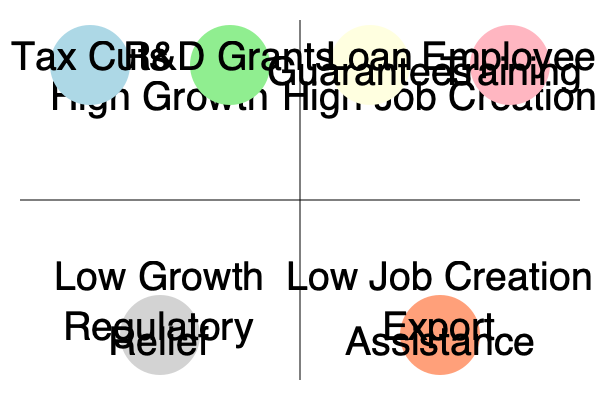Based on the decision tree diagram comparing various economic incentives for small businesses, which incentive is likely to be most effective in simultaneously promoting high growth and high job creation? Explain your reasoning using the positioning of the incentives in the quadrants. To answer this question, we need to analyze the position of each economic incentive in the decision tree diagram:

1. The diagram is divided into four quadrants:
   - Top-left: High Growth, Low Job Creation
   - Top-right: High Growth, High Job Creation
   - Bottom-left: Low Growth, Low Job Creation
   - Bottom-right: Low Growth, High Job Creation

2. The economic incentives are positioned as follows:
   - Tax Cuts: High Growth, Low Job Creation
   - R&D Grants: High Growth, Low Job Creation
   - Loan Guarantees: High Growth, High Job Creation
   - Employee Training: High Growth, High Job Creation
   - Regulatory Relief: Low Growth, Low Job Creation
   - Export Assistance: Low Growth, High Job Creation

3. To promote both high growth and high job creation, we need to focus on the top-right quadrant.

4. Two incentives are positioned in the top-right quadrant:
   - Loan Guarantees
   - Employee Training

5. Both of these incentives are expected to contribute to high growth and high job creation. However, we need to choose the most effective one.

6. Loan Guarantees can provide small businesses with access to capital, which can be used for expansion, hiring, and investment in new technologies or equipment. This can lead to both growth and job creation.

7. Employee Training, while beneficial, may have a more direct impact on job quality and productivity rather than immediate growth and job creation.

8. Therefore, Loan Guarantees are likely to be the most effective incentive for simultaneously promoting high growth and high job creation in small businesses.
Answer: Loan Guarantees 